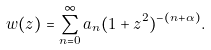<formula> <loc_0><loc_0><loc_500><loc_500>w ( z ) = \sum ^ { \infty } _ { n = 0 } a _ { n } ( 1 + z ^ { 2 } ) ^ { - ( n + \alpha ) } .</formula> 